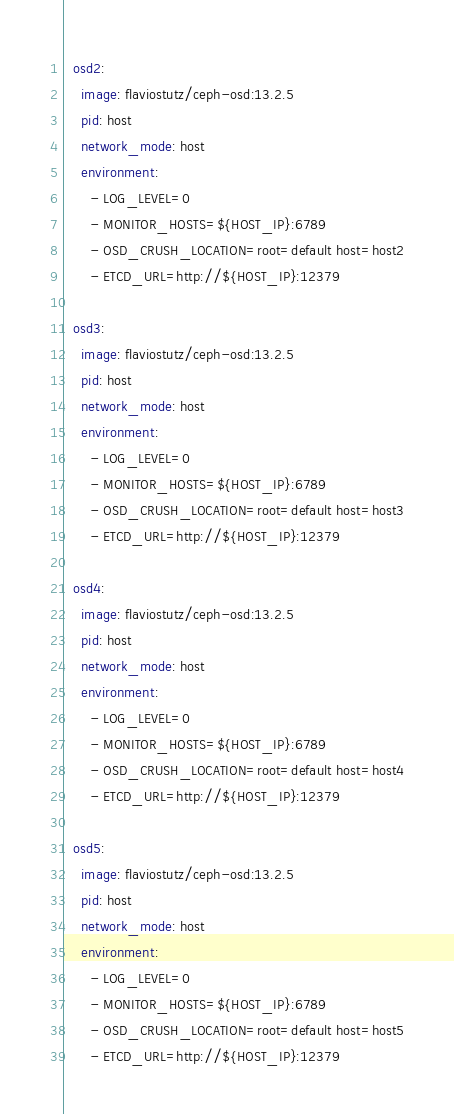Convert code to text. <code><loc_0><loc_0><loc_500><loc_500><_YAML_>  osd2:
    image: flaviostutz/ceph-osd:13.2.5
    pid: host
    network_mode: host
    environment:
      - LOG_LEVEL=0
      - MONITOR_HOSTS=${HOST_IP}:6789
      - OSD_CRUSH_LOCATION=root=default host=host2
      - ETCD_URL=http://${HOST_IP}:12379
  
  osd3:
    image: flaviostutz/ceph-osd:13.2.5
    pid: host
    network_mode: host
    environment:
      - LOG_LEVEL=0
      - MONITOR_HOSTS=${HOST_IP}:6789
      - OSD_CRUSH_LOCATION=root=default host=host3
      - ETCD_URL=http://${HOST_IP}:12379
  
  osd4:
    image: flaviostutz/ceph-osd:13.2.5
    pid: host
    network_mode: host
    environment:
      - LOG_LEVEL=0
      - MONITOR_HOSTS=${HOST_IP}:6789
      - OSD_CRUSH_LOCATION=root=default host=host4
      - ETCD_URL=http://${HOST_IP}:12379

  osd5:
    image: flaviostutz/ceph-osd:13.2.5
    pid: host
    network_mode: host
    environment:
      - LOG_LEVEL=0
      - MONITOR_HOSTS=${HOST_IP}:6789
      - OSD_CRUSH_LOCATION=root=default host=host5
      - ETCD_URL=http://${HOST_IP}:12379
</code> 